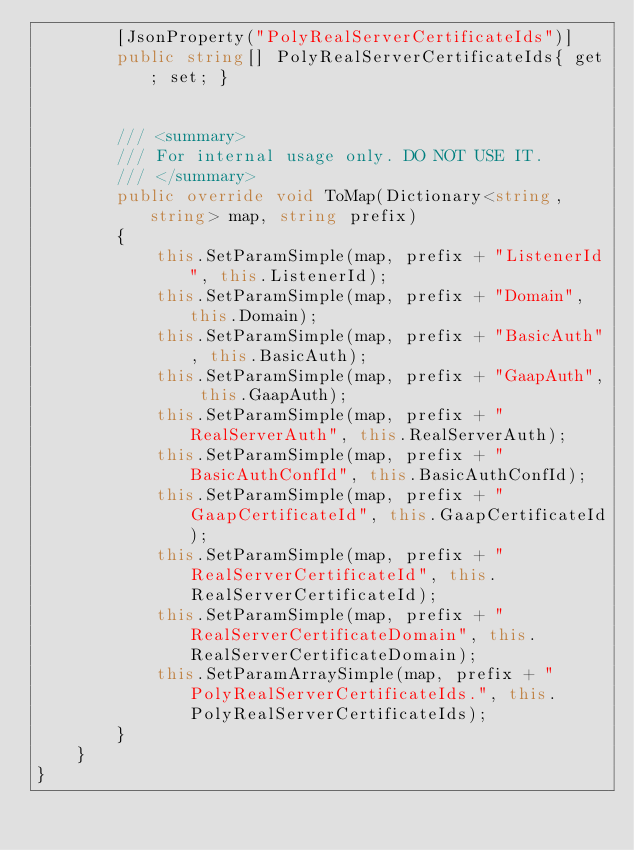Convert code to text. <code><loc_0><loc_0><loc_500><loc_500><_C#_>        [JsonProperty("PolyRealServerCertificateIds")]
        public string[] PolyRealServerCertificateIds{ get; set; }


        /// <summary>
        /// For internal usage only. DO NOT USE IT.
        /// </summary>
        public override void ToMap(Dictionary<string, string> map, string prefix)
        {
            this.SetParamSimple(map, prefix + "ListenerId", this.ListenerId);
            this.SetParamSimple(map, prefix + "Domain", this.Domain);
            this.SetParamSimple(map, prefix + "BasicAuth", this.BasicAuth);
            this.SetParamSimple(map, prefix + "GaapAuth", this.GaapAuth);
            this.SetParamSimple(map, prefix + "RealServerAuth", this.RealServerAuth);
            this.SetParamSimple(map, prefix + "BasicAuthConfId", this.BasicAuthConfId);
            this.SetParamSimple(map, prefix + "GaapCertificateId", this.GaapCertificateId);
            this.SetParamSimple(map, prefix + "RealServerCertificateId", this.RealServerCertificateId);
            this.SetParamSimple(map, prefix + "RealServerCertificateDomain", this.RealServerCertificateDomain);
            this.SetParamArraySimple(map, prefix + "PolyRealServerCertificateIds.", this.PolyRealServerCertificateIds);
        }
    }
}

</code> 